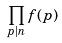Convert formula to latex. <formula><loc_0><loc_0><loc_500><loc_500>\prod _ { p | n } f ( p )</formula> 